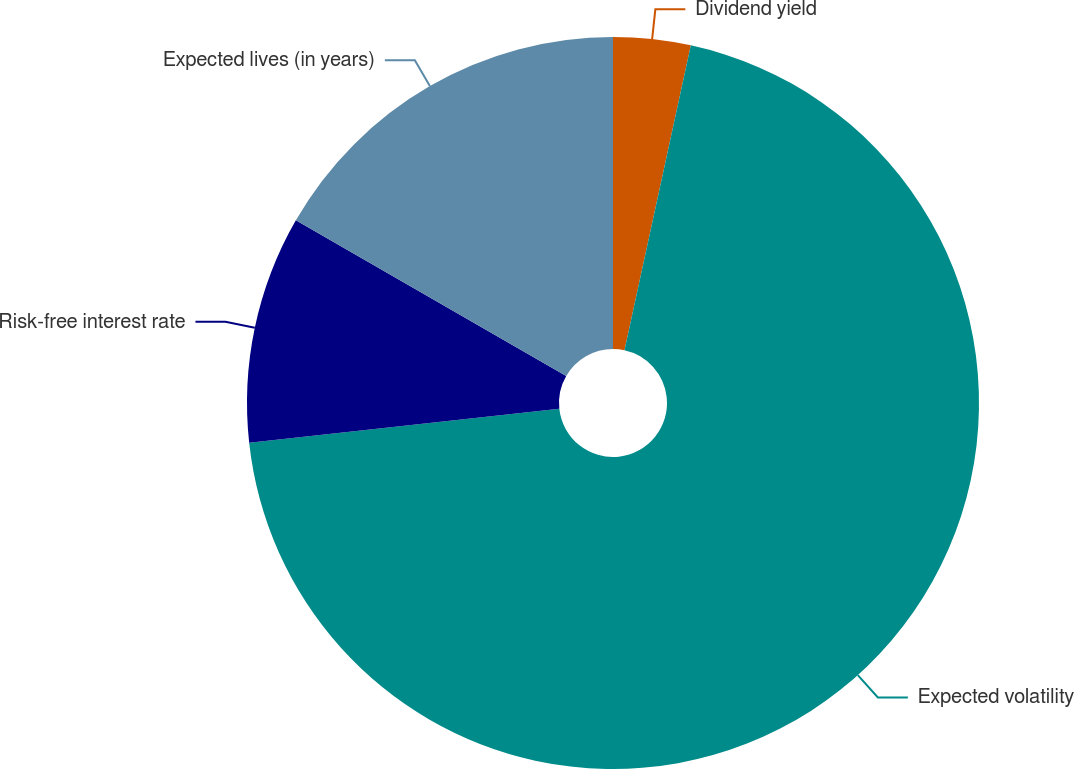Convert chart to OTSL. <chart><loc_0><loc_0><loc_500><loc_500><pie_chart><fcel>Dividend yield<fcel>Expected volatility<fcel>Risk-free interest rate<fcel>Expected lives (in years)<nl><fcel>3.41%<fcel>69.85%<fcel>10.05%<fcel>16.68%<nl></chart> 